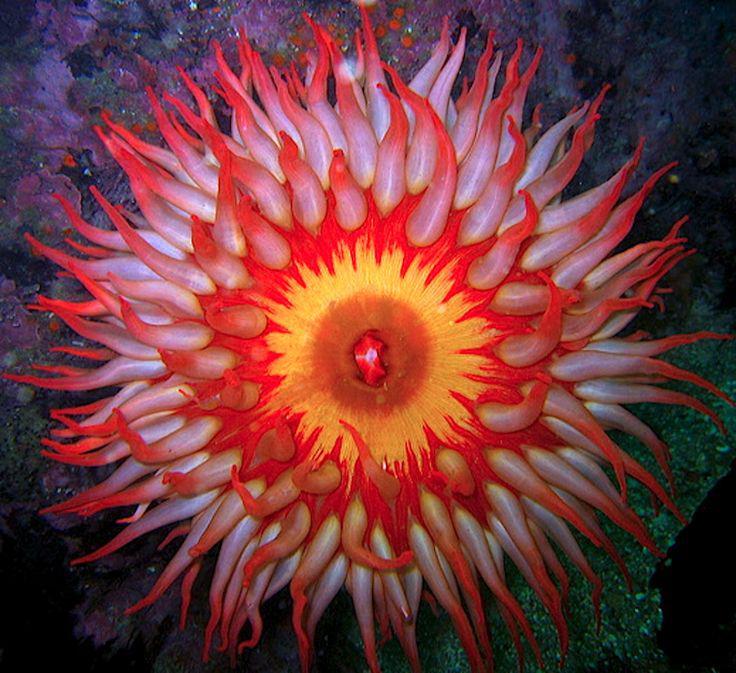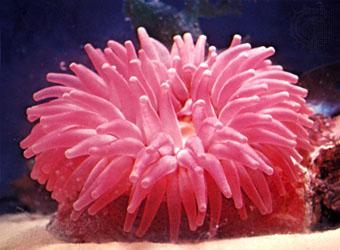The first image is the image on the left, the second image is the image on the right. Evaluate the accuracy of this statement regarding the images: "At least one image shows a striped clown fish swimming among anemone tendrils.". Is it true? Answer yes or no. No. The first image is the image on the left, the second image is the image on the right. Examine the images to the left and right. Is the description "There is a pink Sea anemone in the right image." accurate? Answer yes or no. Yes. 